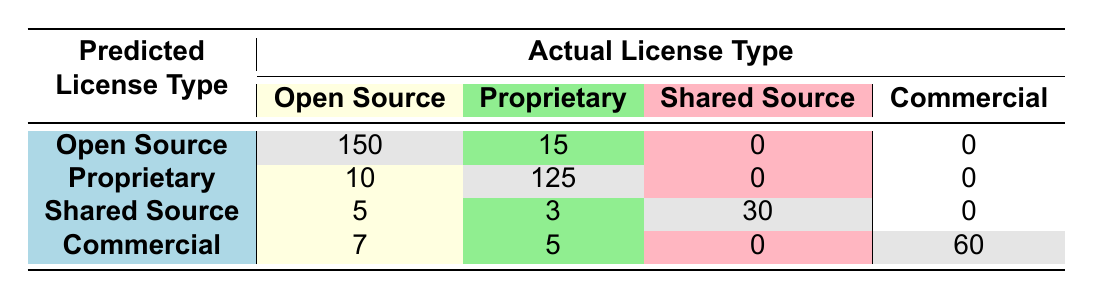What is the total number of actual Open Source licenses predicted as Open Source? In the table, the row labeled 'Open Source' under the 'Predicted License Type' column shows an actual license count of 150. This indicates that 150 actual Open Source licenses were correctly identified as Open Source.
Answer: 150 How many licenses were misclassified as Proprietary when they were actually Open Source? From the 'Open Source' row under the 'Predicted License Type', there is a count of 15 licenses that were predicted as Open Source but were actually Proprietary.
Answer: 15 What is the total number of licenses predicted as Shared Source? Adding the counts from the 'Shared Source' row, we have 30 (Shared Source to Shared Source) + 5 (Shared Source to Open Source) + 3 (Shared Source to Proprietary), which equals 38.
Answer: 38 Are there any licenses predicted as Commercial that were classified under Shared Source? Looking at the table, there is no count in the 'Commercial' row under the 'Shared Source' column, indicating that there were zero licenses incorrectly classified in that manner.
Answer: No What percentage of the total licenses are correctly predicted as Open Source? The total number of licenses is calculated as 150 (Open Source) + 15 (Open Source as Proprietary) + 10 (Proprietary as Open Source) + 125 (Proprietary) + 30 (Shared Source) + 5 (Shared Source as Open Source) + 3 (Shared Source as Proprietary) + 60 (Commercial) + 7 (Commercial as Open Source) + 5 (Commercial as Proprietary) = 410. The correctly predicted Open Source licenses are 150. The percentage is (150/410) * 100 = 36.59%.
Answer: 36.59% What is the difference between the actual number of Proprietary licenses and the predicted count of Proprietary licenses? The actual count of Proprietary licenses is 15 + 125 + 0 + 0, totaling 140. The predicted count of Proprietary licenses is 10 + 125 + 0 + 0, totaling 135. The difference is 140 - 135 = 5, meaning there are 5 more actual Proprietary licenses than predicted.
Answer: 5 What is the total number of licenses predicted as Commercial that were actually either Open Source or Proprietary? From the 'Commercial' row, we see 7 (predicted Commercial but actually Open Source) and 5 (predicted Commercial but actually Proprietary). Adding these counts gives us 7 + 5 = 12.
Answer: 12 How many actual licenses were classified as Shared Source? The total count of actual Shared Source licenses is from the 'Shared Source' row, which indicates 30 licenses were correctly predicted as Shared Source, with no licenses incorrectly classified as Shared Source in the other rows, yielding a total of 30.
Answer: 30 Is it true that more licenses were predicted as Open Source than as Commercial? Yes, adding the numbers, we find 150 licenses were predicted as Open Source while only 60 were predicted as Commercial, confirming that more licenses were predicted as Open Source.
Answer: Yes 